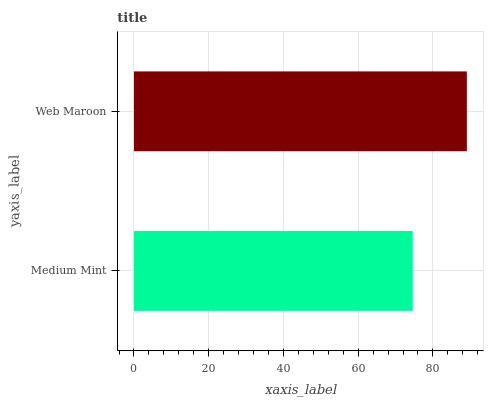Is Medium Mint the minimum?
Answer yes or no. Yes. Is Web Maroon the maximum?
Answer yes or no. Yes. Is Web Maroon the minimum?
Answer yes or no. No. Is Web Maroon greater than Medium Mint?
Answer yes or no. Yes. Is Medium Mint less than Web Maroon?
Answer yes or no. Yes. Is Medium Mint greater than Web Maroon?
Answer yes or no. No. Is Web Maroon less than Medium Mint?
Answer yes or no. No. Is Web Maroon the high median?
Answer yes or no. Yes. Is Medium Mint the low median?
Answer yes or no. Yes. Is Medium Mint the high median?
Answer yes or no. No. Is Web Maroon the low median?
Answer yes or no. No. 